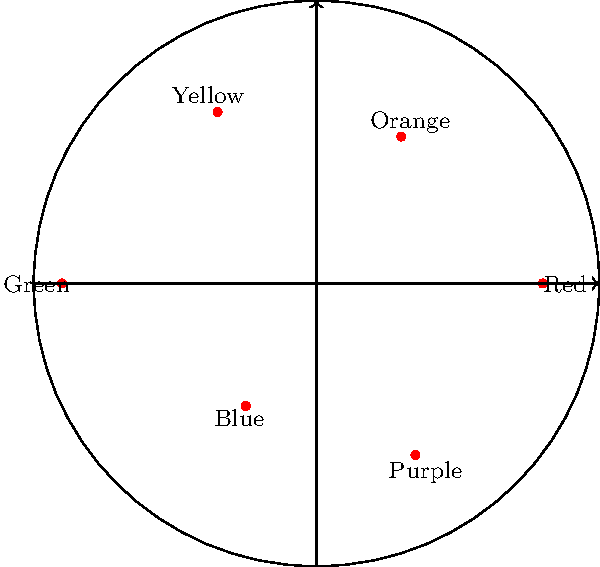In a regional art exhibition, you've plotted the prevalence of different colors used by local artists on a polar coordinate system. Each color's distance from the origin represents its frequency of use, with the outermost circle representing 100% usage. Based on the graph, which color appears to be most frequently used by the artists in your region? To determine which color is most frequently used, we need to identify the point that is farthest from the origin in the polar coordinate system. The distance from the origin represents the frequency of use for each color.

Let's analyze each color's position:

1. Red: Located at 0°, relatively far from the origin
2. Orange: At 60°, closer to the origin than Red
3. Yellow: At 120°, further from the origin than Orange
4. Green: At 180°, appears to be the farthest point from the origin
5. Blue: At 240°, closest to the origin among all colors
6. Purple: At 300°, further from the origin than Blue but not as far as Green

By visually comparing the distances, we can see that Green, positioned at 180°, extends furthest from the center of the circle. This indicates that Green is the most frequently used color by the local artists in your region.
Answer: Green 